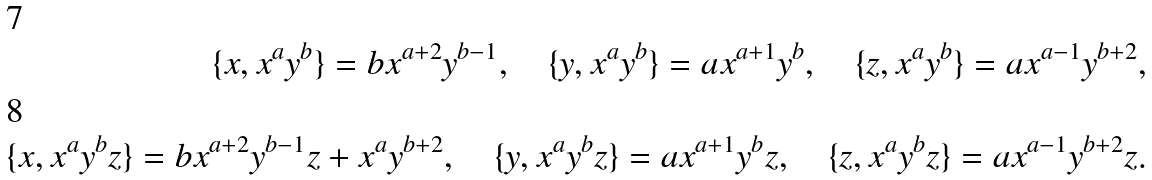Convert formula to latex. <formula><loc_0><loc_0><loc_500><loc_500>\{ x , x ^ { a } y ^ { b } \} = b x ^ { a + 2 } y ^ { b - 1 } , \quad \{ y , x ^ { a } y ^ { b } \} = a x ^ { a + 1 } y ^ { b } , \quad \{ z , x ^ { a } y ^ { b } \} = a x ^ { a - 1 } y ^ { b + 2 } , \\ \{ x , x ^ { a } y ^ { b } z \} = b x ^ { a + 2 } y ^ { b - 1 } z + x ^ { a } y ^ { b + 2 } , \quad \{ y , x ^ { a } y ^ { b } z \} = a x ^ { a + 1 } y ^ { b } z , \quad \{ z , x ^ { a } y ^ { b } z \} = a x ^ { a - 1 } y ^ { b + 2 } z .</formula> 